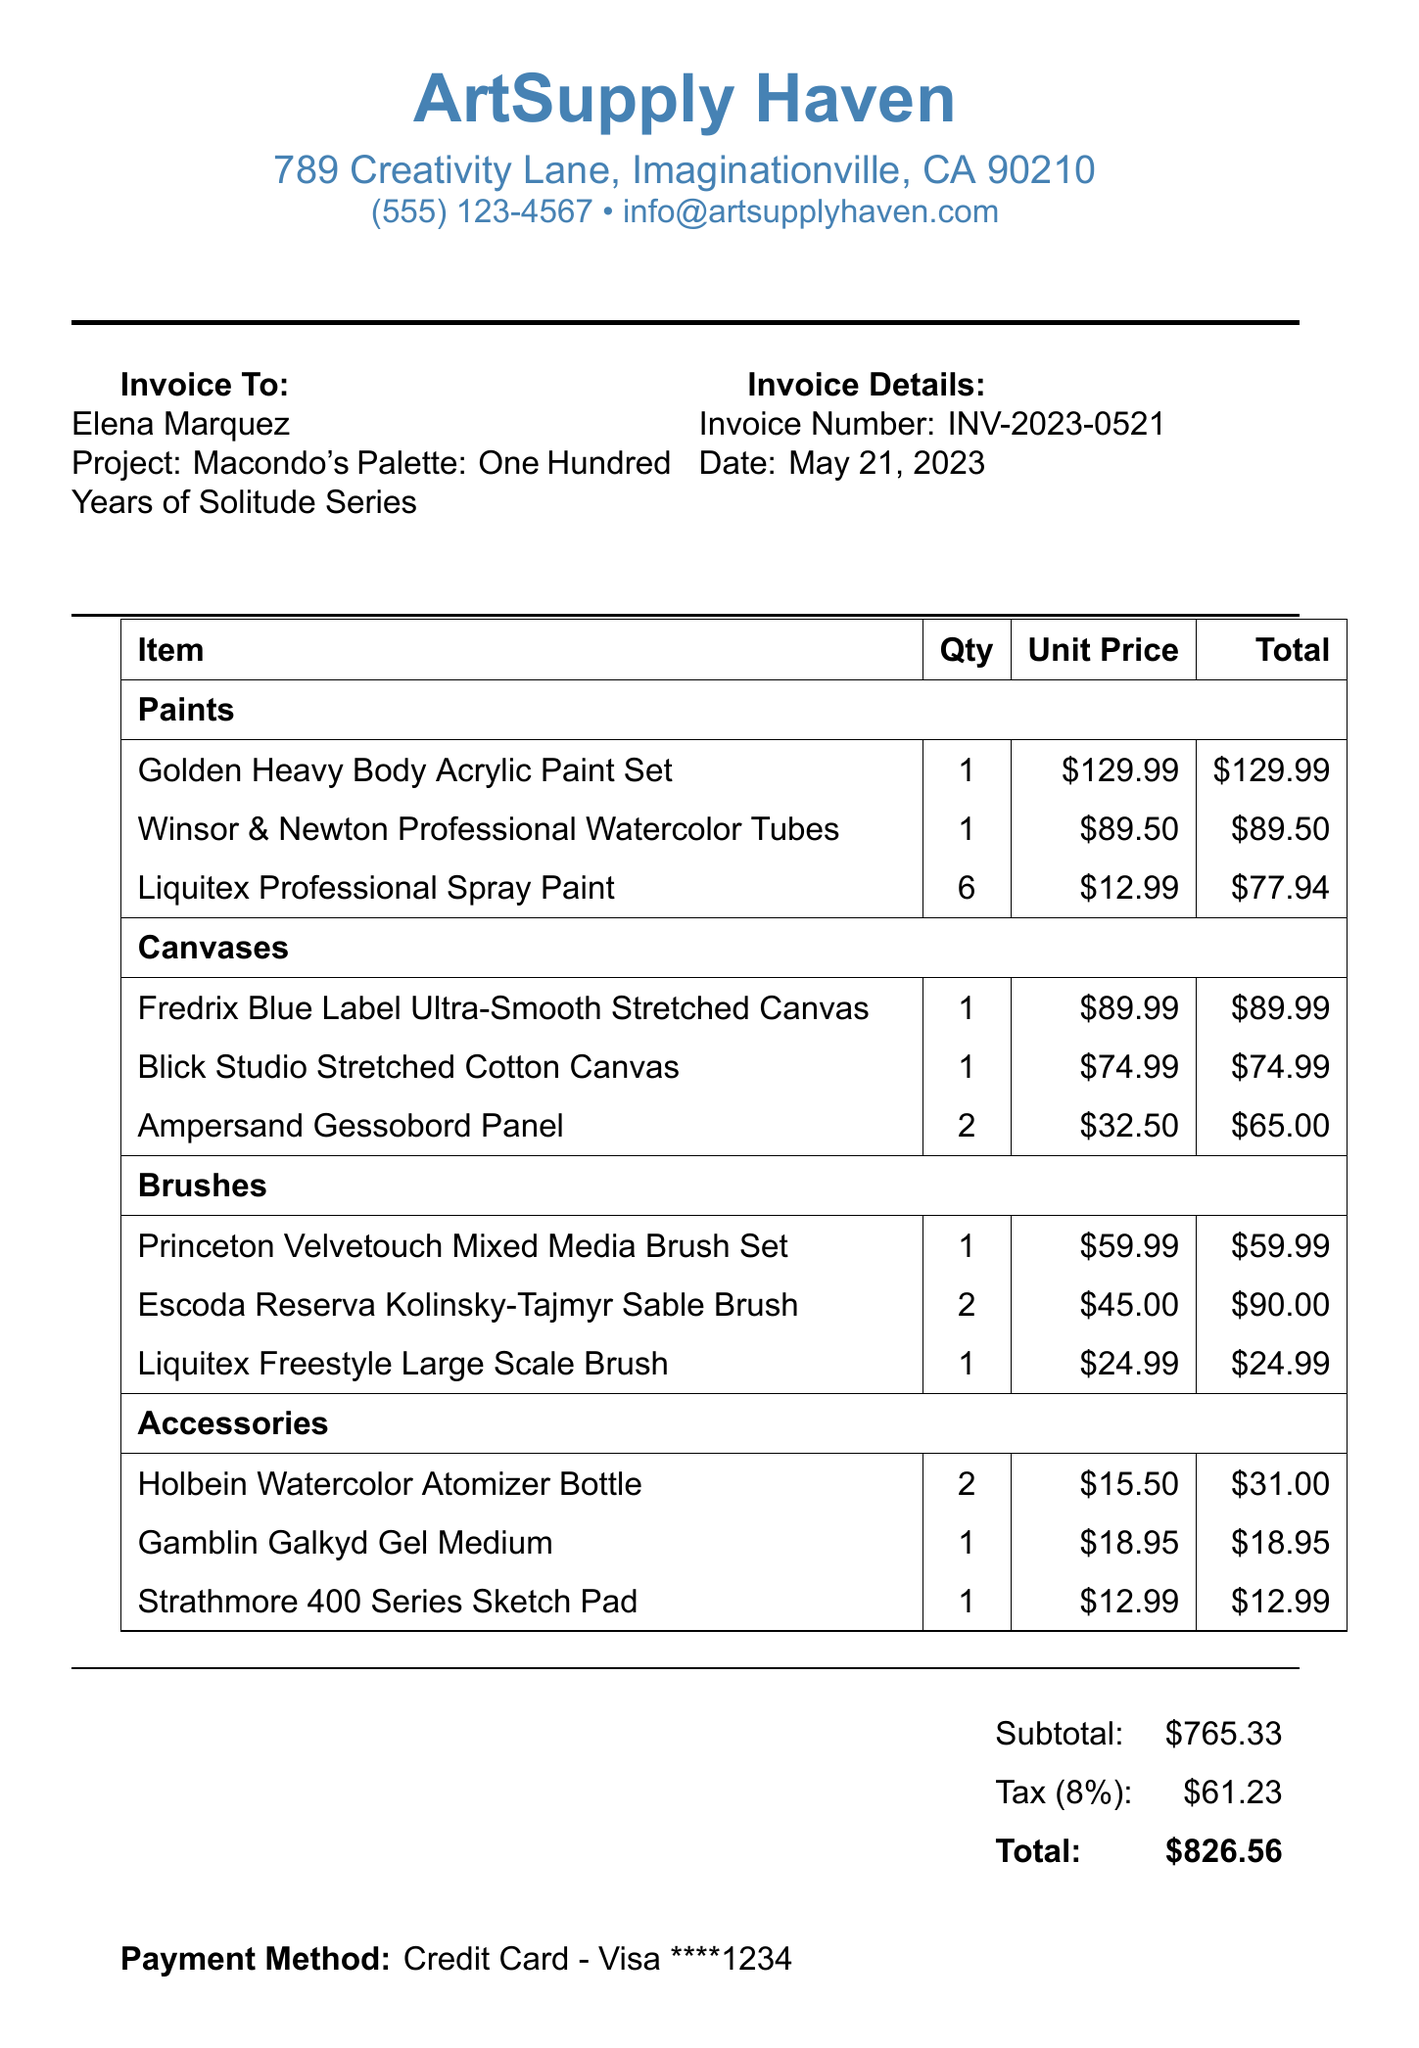what is the invoice number? The invoice number is provided at the top of the document.
Answer: INV-2023-0521 who is the artist? The artist's name is mentioned in the invoice details section.
Answer: Elena Marquez what is the total amount on the invoice? The total amount is the sum of subtotal and tax, clearly stated at the bottom.
Answer: $826.56 how many colors are in the Golden Heavy Body Acrylic Paint Set? The item description specifies the number of colors included in the set.
Answer: 10 colors what is the quantity of the Winsor & Newton Professional Watercolor Tubes purchased? The invoice lists the quantity for each item, indicating how many were bought.
Answer: 1 how much does each Escoda Reserva Kolinsky-Tajmyr Sable Brush cost? The unit price for the brush is provided in the itemized list.
Answer: $45.00 which store is the art supplies purchased from? The store's name is highlighted at the top of the document.
Answer: ArtSupply Haven what is the subtotal of the items before tax? The subtotal is listed separately before the tax amount in the summary section.
Answer: $765.33 how many Ampersand Gessobord Panels were ordered? The quantity for this item is specified in the document.
Answer: 2 